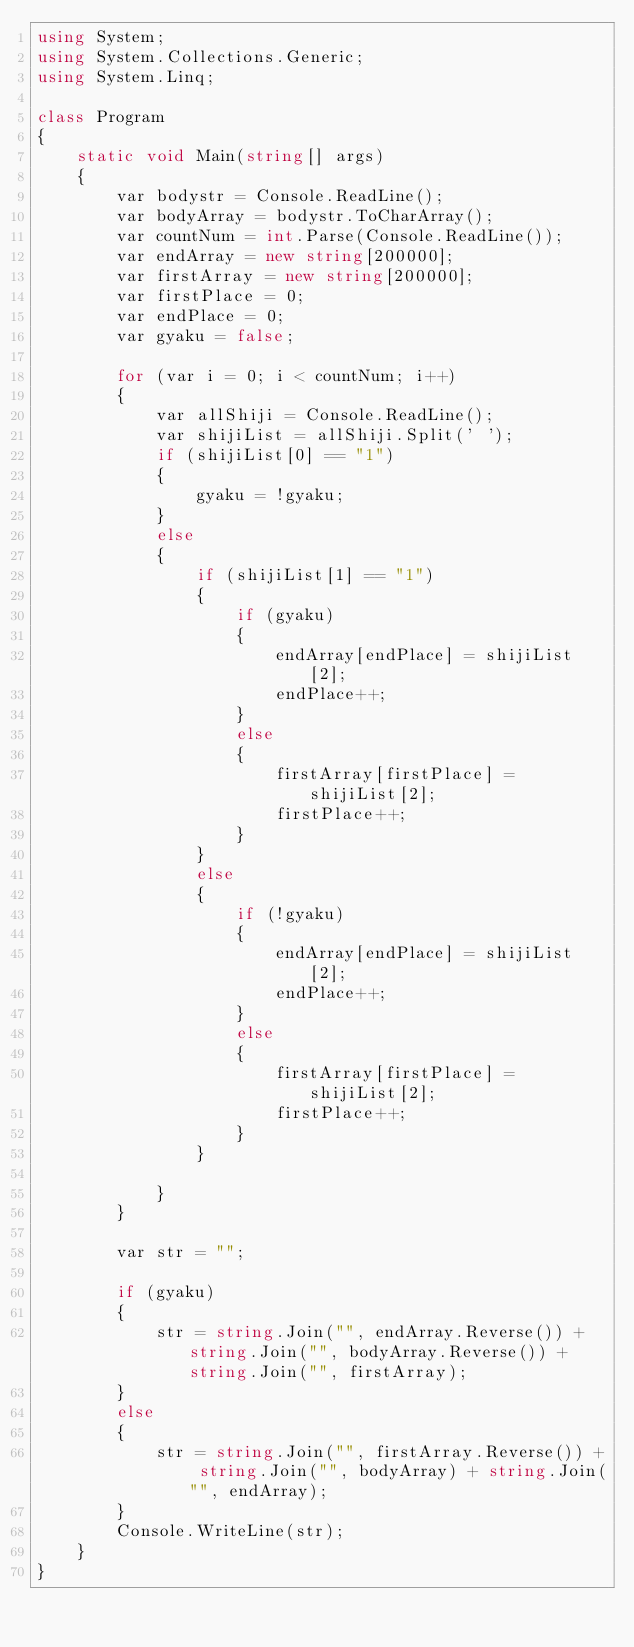<code> <loc_0><loc_0><loc_500><loc_500><_C#_>using System;
using System.Collections.Generic;
using System.Linq;

class Program
{
    static void Main(string[] args)
    {
        var bodystr = Console.ReadLine();
        var bodyArray = bodystr.ToCharArray();
        var countNum = int.Parse(Console.ReadLine());
        var endArray = new string[200000];
        var firstArray = new string[200000];
        var firstPlace = 0;
        var endPlace = 0;
        var gyaku = false;

        for (var i = 0; i < countNum; i++)
        {
            var allShiji = Console.ReadLine();
            var shijiList = allShiji.Split(' ');
            if (shijiList[0] == "1")
            {
                gyaku = !gyaku;
            }
            else
            {
                if (shijiList[1] == "1")
                {
                    if (gyaku)
                    {
                        endArray[endPlace] = shijiList[2];
                        endPlace++;
                    }
                    else
                    {
                        firstArray[firstPlace] = shijiList[2];
                        firstPlace++;
                    }
                }
                else
                {
                    if (!gyaku)
                    {
                        endArray[endPlace] = shijiList[2];
                        endPlace++;
                    }
                    else
                    {
                        firstArray[firstPlace] = shijiList[2];
                        firstPlace++;
                    }
                }

            }
        }

        var str = "";

        if (gyaku)
        {
            str = string.Join("", endArray.Reverse()) + string.Join("", bodyArray.Reverse()) + string.Join("", firstArray);
        }
        else
        {
            str = string.Join("", firstArray.Reverse()) + string.Join("", bodyArray) + string.Join("", endArray);
        }
        Console.WriteLine(str);
    }
}</code> 